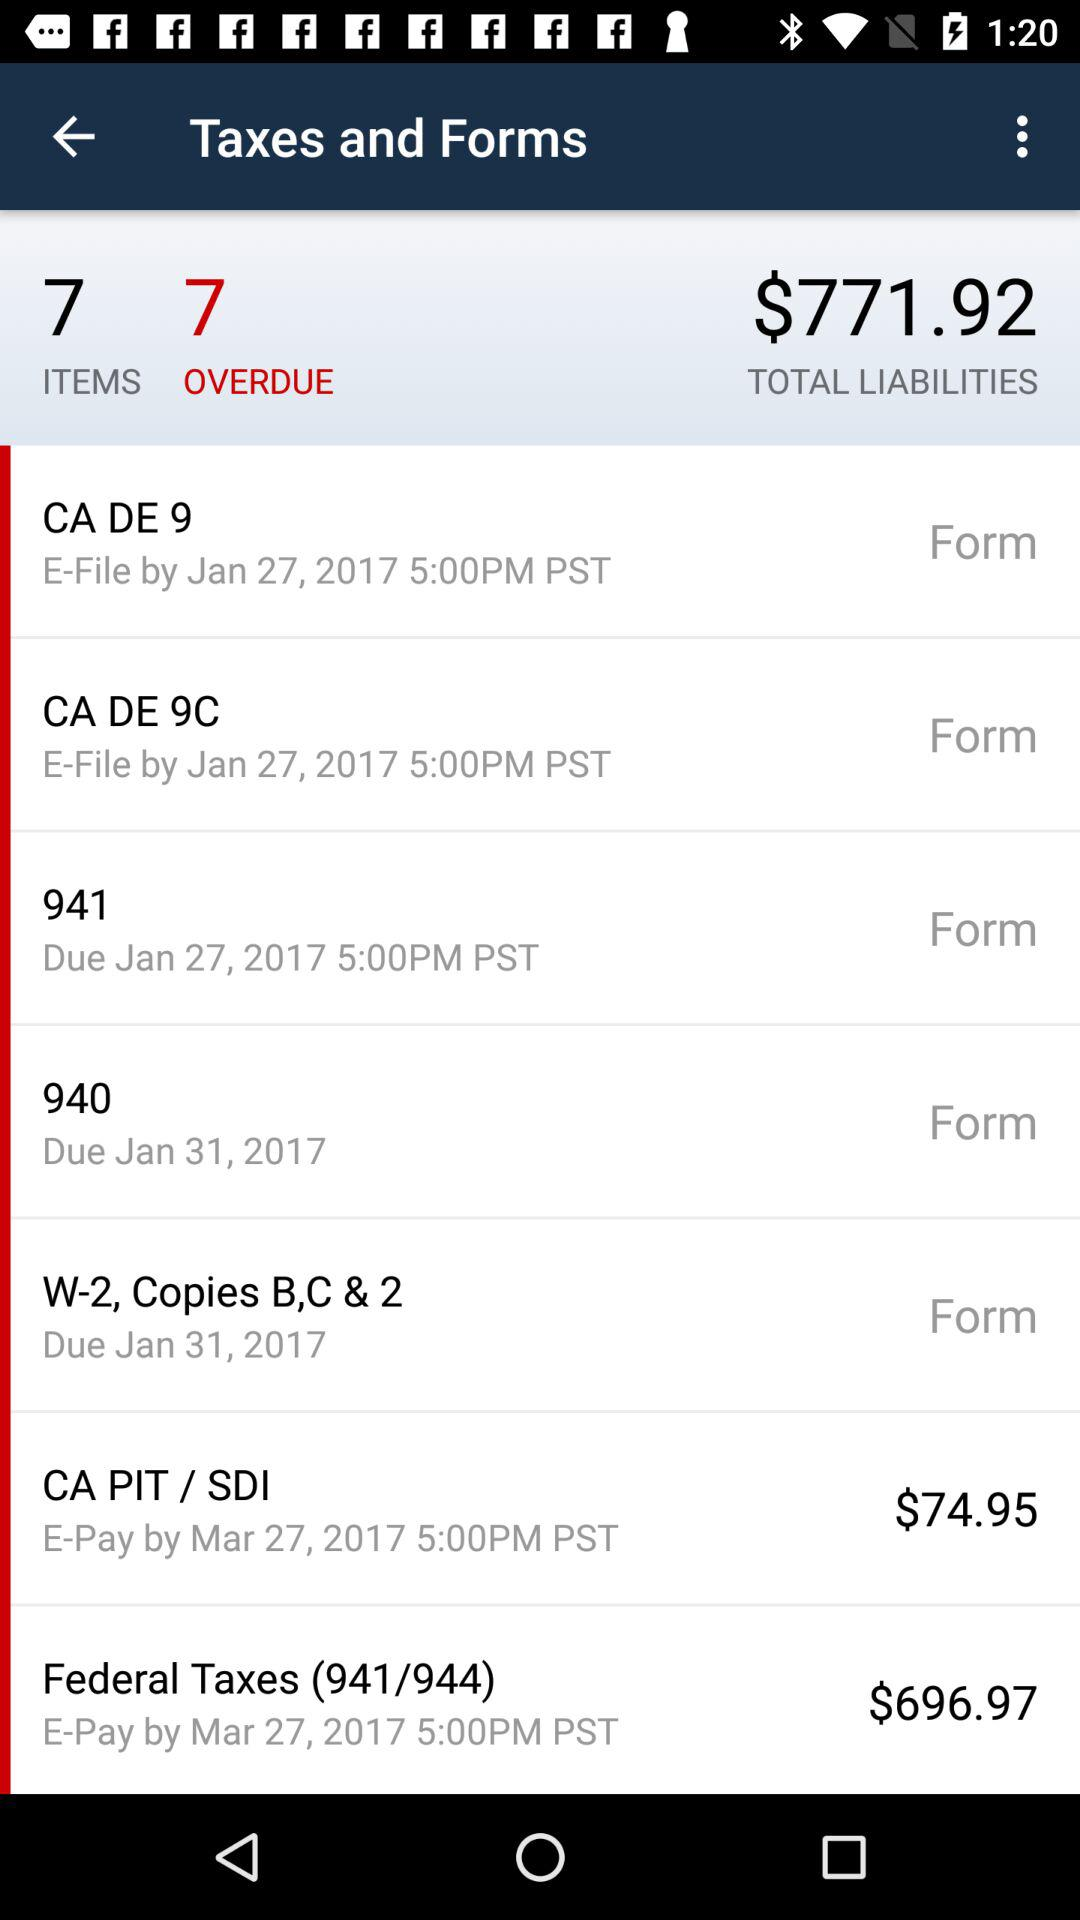How many overdue are there? There are 7 overdue. 